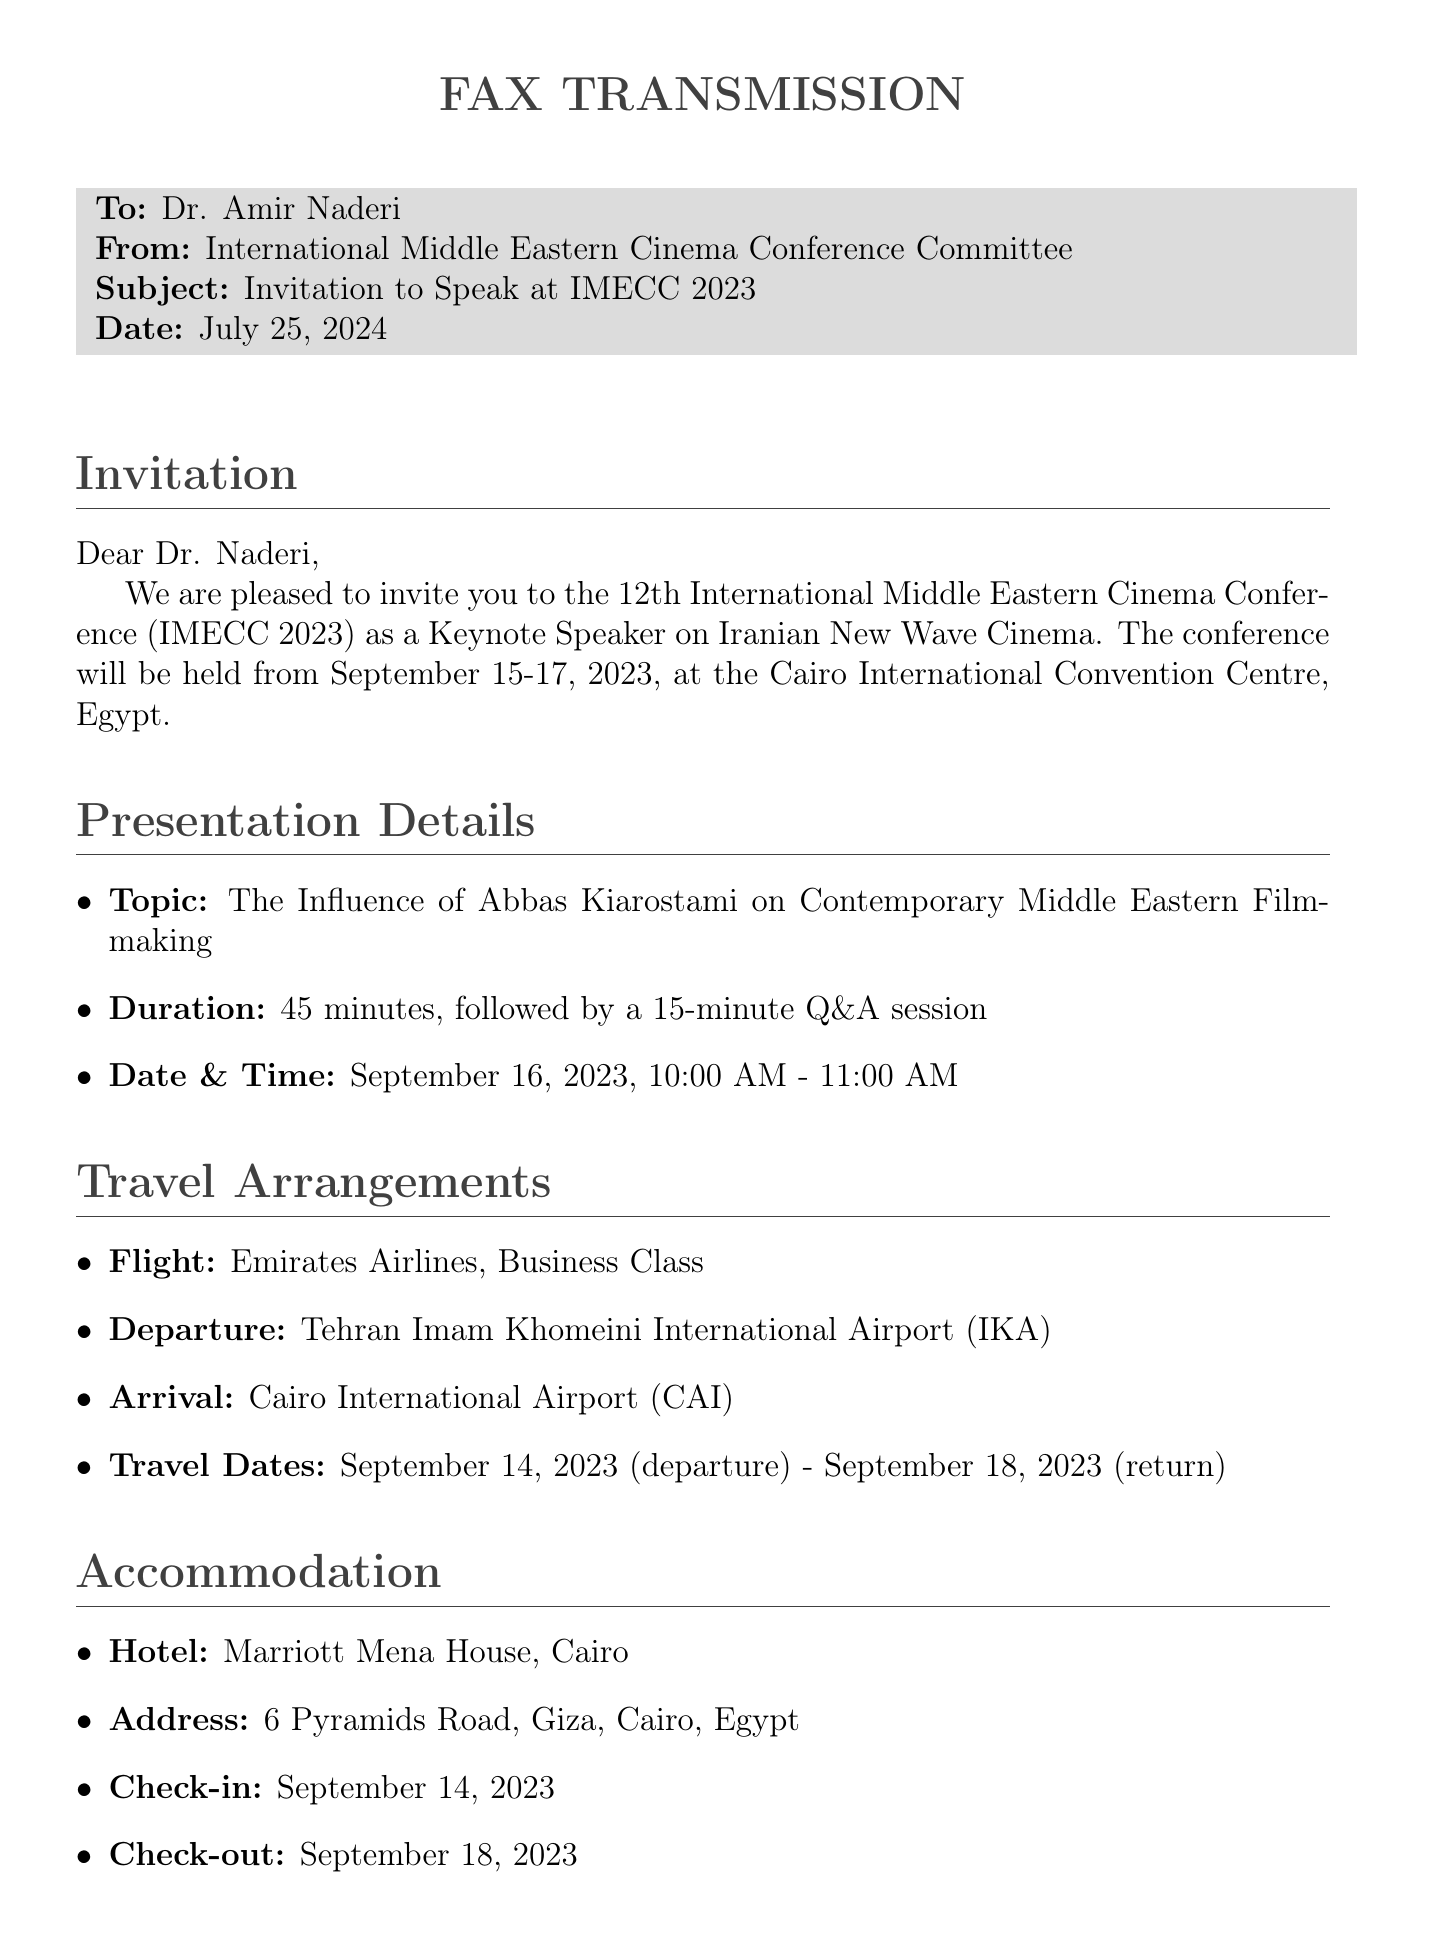What are the dates of the conference? The dates of the conference are clearly stated in the document as September 15-17, 2023.
Answer: September 15-17, 2023 What is the topic of the keynote presentation? The topic of the keynote presentation is provided in the "Presentation Details" section.
Answer: The Influence of Abbas Kiarostami on Contemporary Middle Eastern Filmmaking What is the honorarium amount? The document specifies the honorarium amount in the "Additional Information" section.
Answer: $2,000 USD Which airline is mentioned for the flight? The airline for the flight is mentioned under the "Travel Arrangements" section.
Answer: Emirates Airlines What is the check-out date for the accommodation? The check-out date is provided in the "Accommodation" section of the document.
Answer: September 18, 2023 How long is the keynote presentation? The duration of the keynote presentation is specified in the "Presentation Details" section.
Answer: 45 minutes Who is the conference contact person? The name of the conference contact person is listed in the "Additional Information" section.
Answer: Dr. Laila El Feki On which date is the keynote presentation scheduled? The date of the keynote presentation is given in the "Presentation Details" section.
Answer: September 16, 2023 What city is the conference taking place in? The location of the conference is mentioned in the first section of the document.
Answer: Cairo 